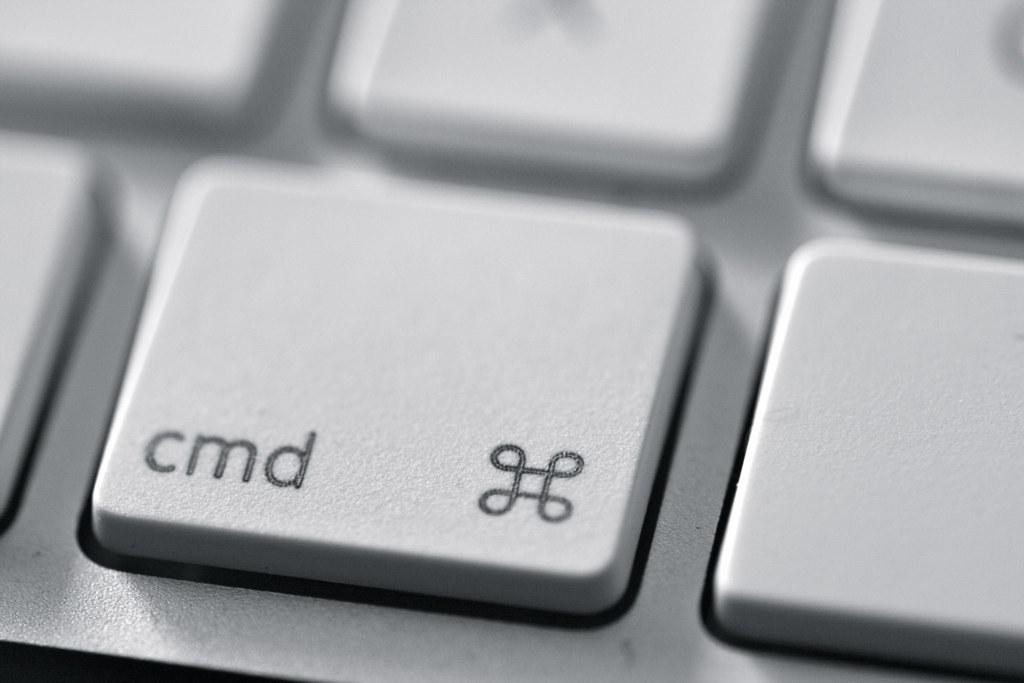<image>
Write a terse but informative summary of the picture. Silver laptop keyboard key that says "CMD" on it. 